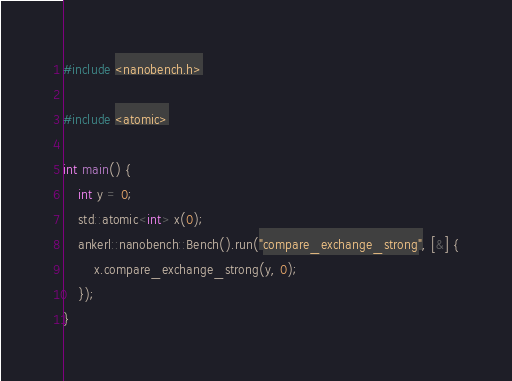Convert code to text. <code><loc_0><loc_0><loc_500><loc_500><_C++_>#include <nanobench.h>

#include <atomic>

int main() {
    int y = 0;
    std::atomic<int> x(0);
    ankerl::nanobench::Bench().run("compare_exchange_strong", [&] {
        x.compare_exchange_strong(y, 0);
    });
}
</code> 